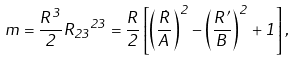Convert formula to latex. <formula><loc_0><loc_0><loc_500><loc_500>m = \frac { R ^ { 3 } } { 2 } { R _ { 2 3 } } ^ { 2 3 } = \frac { R } { 2 } \left [ \left ( \frac { \dot { R } } { A } \right ) ^ { 2 } - \left ( \frac { R ^ { \prime } } { B } \right ) ^ { 2 } + 1 \right ] ,</formula> 